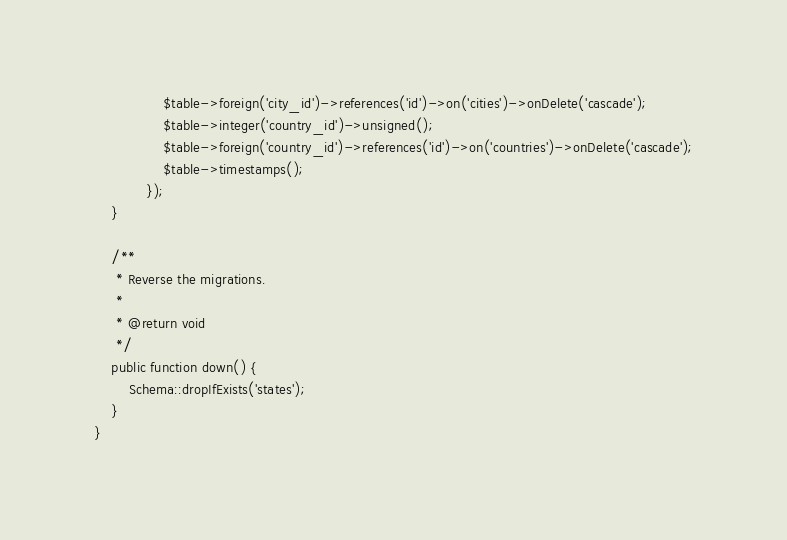<code> <loc_0><loc_0><loc_500><loc_500><_PHP_>				$table->foreign('city_id')->references('id')->on('cities')->onDelete('cascade');
				$table->integer('country_id')->unsigned();
				$table->foreign('country_id')->references('id')->on('countries')->onDelete('cascade');
				$table->timestamps();
			});
	}

	/**
	 * Reverse the migrations.
	 *
	 * @return void
	 */
	public function down() {
		Schema::dropIfExists('states');
	}
}
</code> 